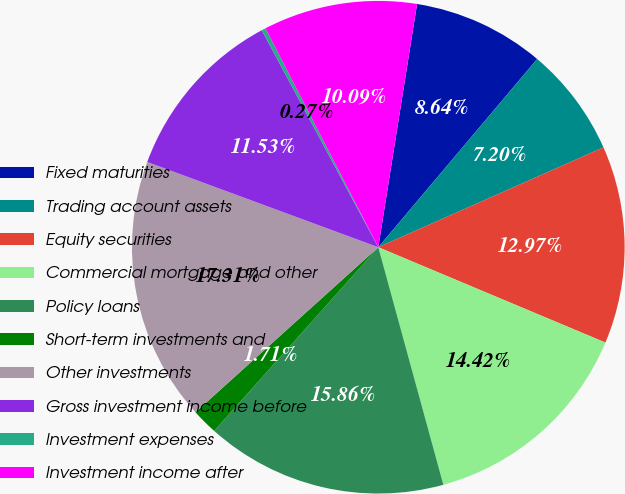<chart> <loc_0><loc_0><loc_500><loc_500><pie_chart><fcel>Fixed maturities<fcel>Trading account assets<fcel>Equity securities<fcel>Commercial mortgage and other<fcel>Policy loans<fcel>Short-term investments and<fcel>Other investments<fcel>Gross investment income before<fcel>Investment expenses<fcel>Investment income after<nl><fcel>8.64%<fcel>7.2%<fcel>12.97%<fcel>14.42%<fcel>15.86%<fcel>1.71%<fcel>17.31%<fcel>11.53%<fcel>0.27%<fcel>10.09%<nl></chart> 